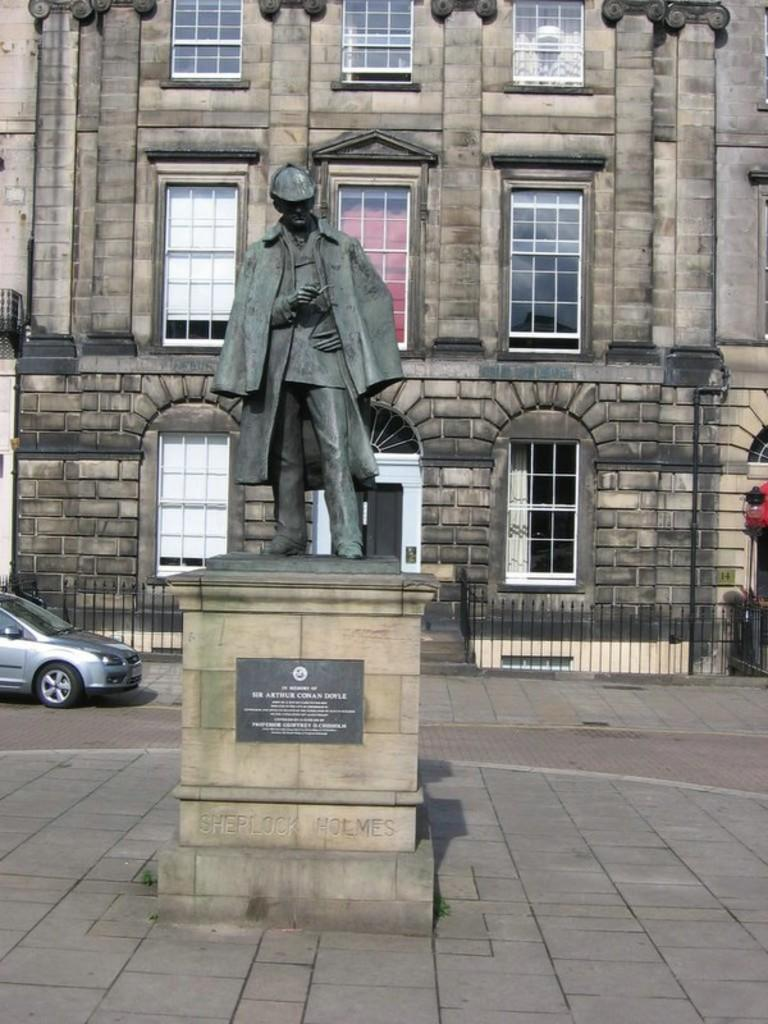What is the main subject in the image? There is a statue in the image. What can be seen near the statue? There is a name board in the image. What is visible on the road in the image? There is a car on the road in the image. What type of structure is present in the image? There is a building with windows in the image. What type of window treatment is visible in the image? There are curtains in the image. What other objects can be seen in the image? There is a pole and a light in the image. How does the statue produce steam in the image? The statue does not produce steam in the image; there is no mention of steam in the provided facts. 